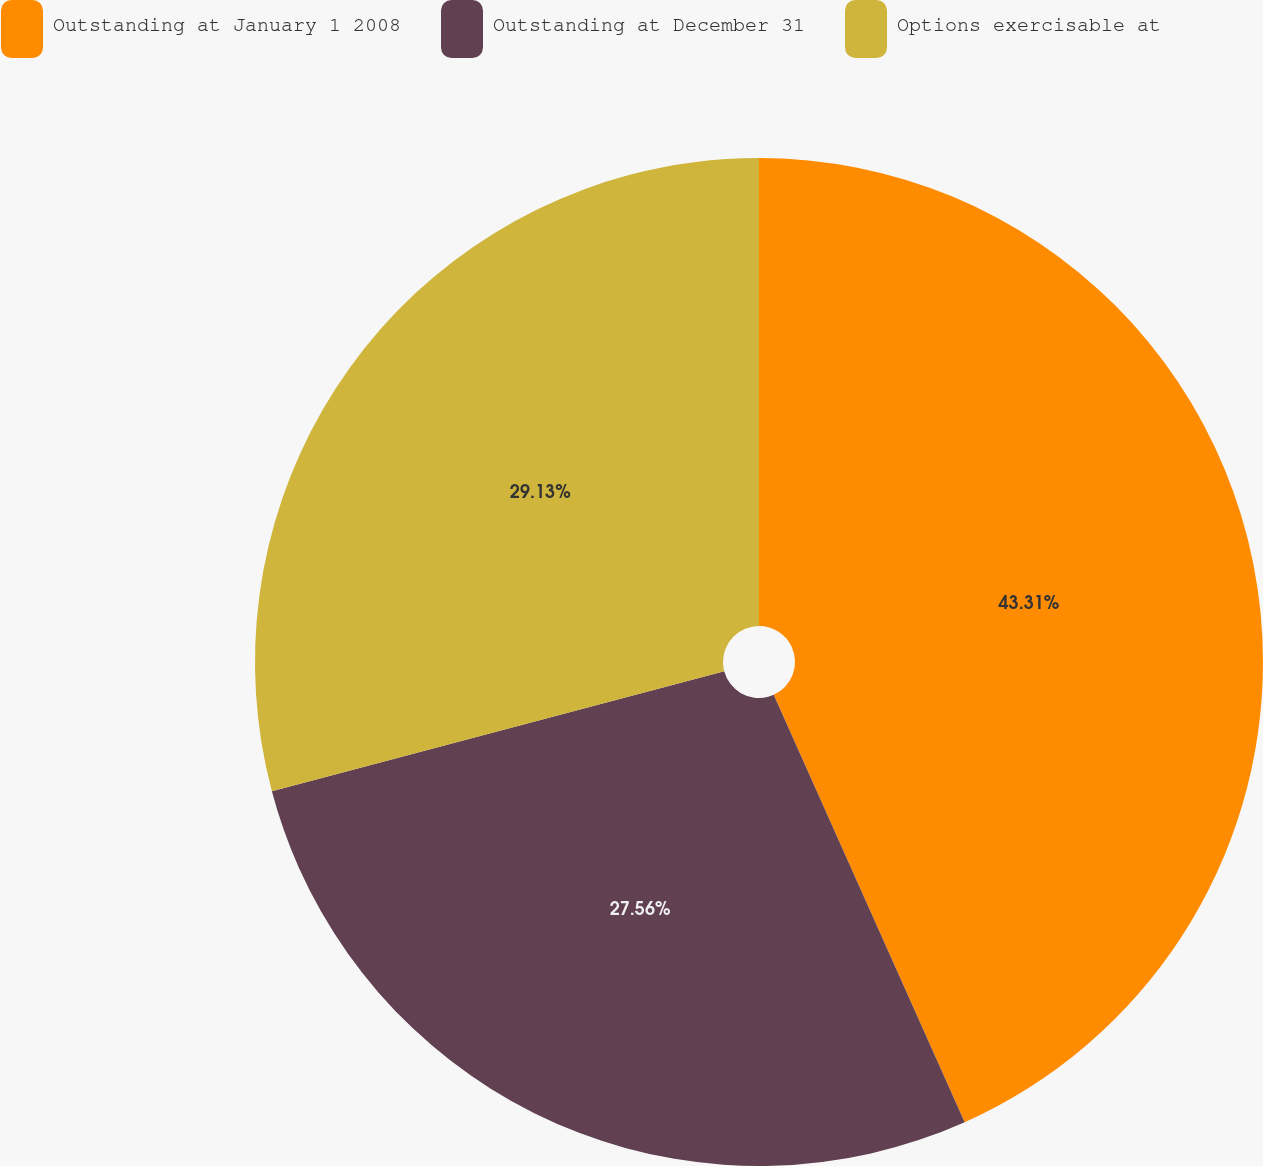Convert chart. <chart><loc_0><loc_0><loc_500><loc_500><pie_chart><fcel>Outstanding at January 1 2008<fcel>Outstanding at December 31<fcel>Options exercisable at<nl><fcel>43.31%<fcel>27.56%<fcel>29.13%<nl></chart> 